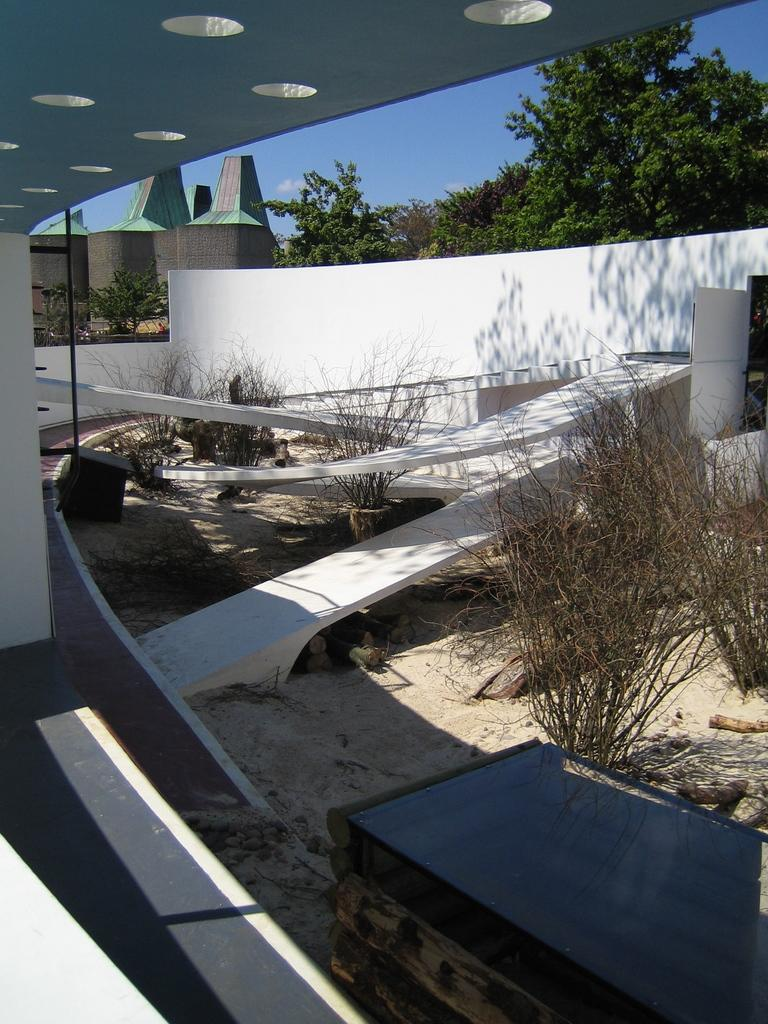What type of structures can be seen in the image? There are buildings in the image. What is the purpose of the wall in the image? The wall serves as a barrier or boundary in the image. What type of vegetation is present in the image? There are plants and trees in the image. What is visible in the background of the image? The sky is visible in the image, and clouds are present in the sky. What type of print can be seen on the spade used to dig the wall in the image? There is no spade or print visible in the image; it features buildings, a wall, plants, trees, and a sky with clouds. What type of shock can be seen affecting the trees in the image? There is no shock or any indication of an abnormal event affecting the trees in the image; they appear to be growing naturally. 